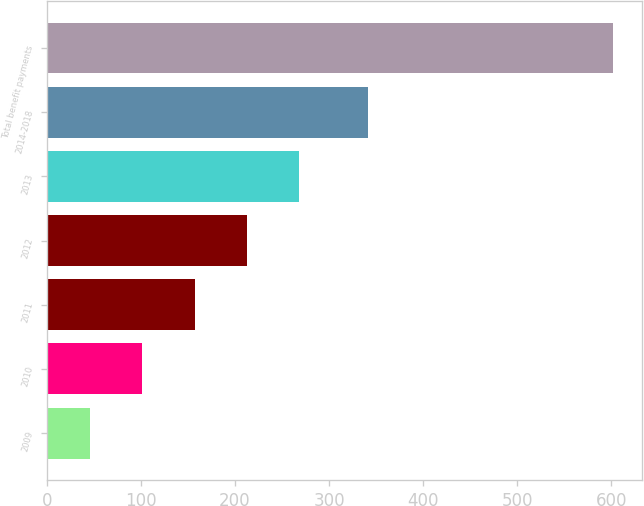Convert chart. <chart><loc_0><loc_0><loc_500><loc_500><bar_chart><fcel>2009<fcel>2010<fcel>2011<fcel>2012<fcel>2013<fcel>2014-2018<fcel>Total benefit payments<nl><fcel>46<fcel>101.6<fcel>157.2<fcel>212.8<fcel>268.4<fcel>341<fcel>602<nl></chart> 